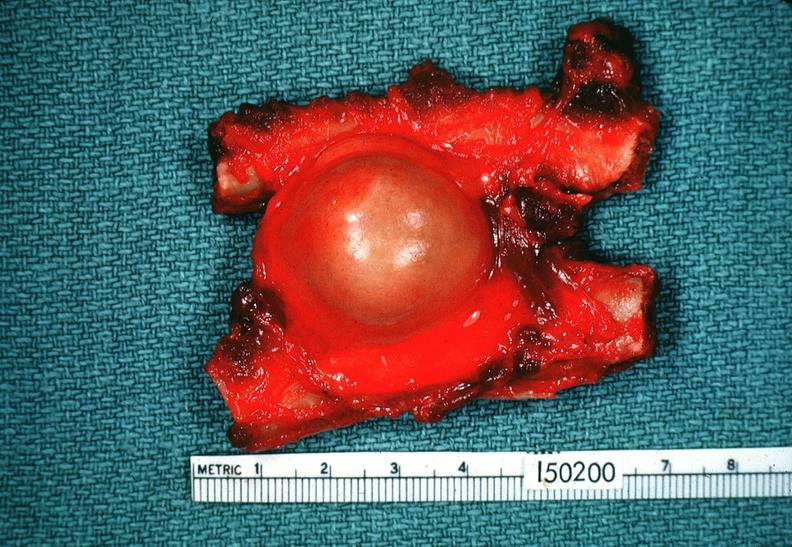what does this image show?
Answer the question using a single word or phrase. Schwannoma 